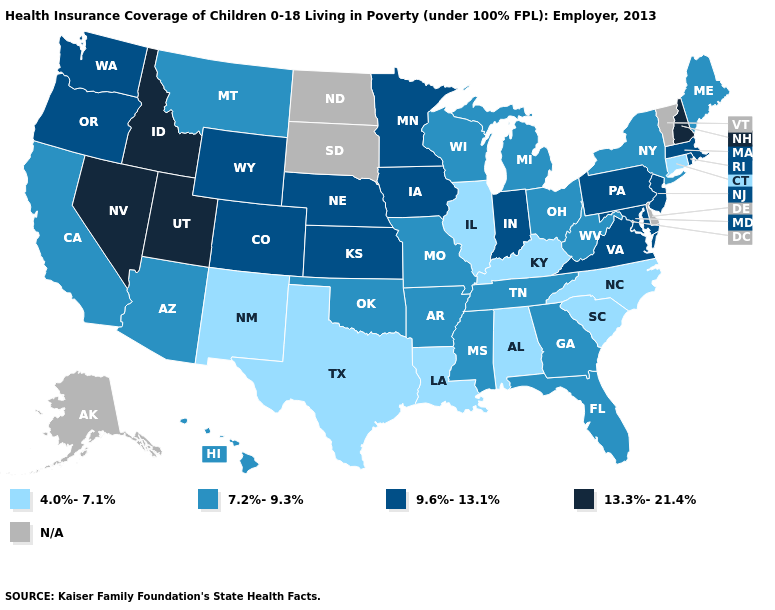Name the states that have a value in the range 13.3%-21.4%?
Give a very brief answer. Idaho, Nevada, New Hampshire, Utah. Which states have the highest value in the USA?
Quick response, please. Idaho, Nevada, New Hampshire, Utah. Does Oregon have the lowest value in the West?
Keep it brief. No. Name the states that have a value in the range N/A?
Give a very brief answer. Alaska, Delaware, North Dakota, South Dakota, Vermont. Is the legend a continuous bar?
Answer briefly. No. What is the highest value in the USA?
Short answer required. 13.3%-21.4%. Name the states that have a value in the range 4.0%-7.1%?
Be succinct. Alabama, Connecticut, Illinois, Kentucky, Louisiana, New Mexico, North Carolina, South Carolina, Texas. Does Idaho have the highest value in the USA?
Be succinct. Yes. Does the map have missing data?
Quick response, please. Yes. Which states hav the highest value in the South?
Write a very short answer. Maryland, Virginia. Which states have the lowest value in the USA?
Quick response, please. Alabama, Connecticut, Illinois, Kentucky, Louisiana, New Mexico, North Carolina, South Carolina, Texas. Name the states that have a value in the range 9.6%-13.1%?
Keep it brief. Colorado, Indiana, Iowa, Kansas, Maryland, Massachusetts, Minnesota, Nebraska, New Jersey, Oregon, Pennsylvania, Rhode Island, Virginia, Washington, Wyoming. Name the states that have a value in the range 4.0%-7.1%?
Be succinct. Alabama, Connecticut, Illinois, Kentucky, Louisiana, New Mexico, North Carolina, South Carolina, Texas. What is the value of Louisiana?
Give a very brief answer. 4.0%-7.1%. Which states have the lowest value in the MidWest?
Be succinct. Illinois. 